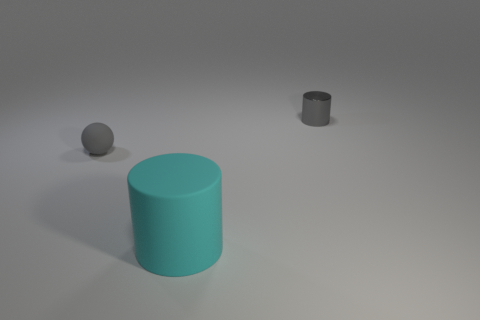Can you describe the colors of the objects in the image? Certainly! There are three objects in the image and they all appear to be monochromatic. The largest cylinder has a turquoise hue, the smaller cylinder seems to be a shade of dark gray, and the sphere is a neutral gray. What could these objects represent in a symbolic manner? These objects might symbolize different sizes and strengths in a community, with the large turquoise cylinder representing the core foundation or a leader, the smaller gray cylinder as the emerging talent or support system, and the small sphere as the unity or completeness of the group. 